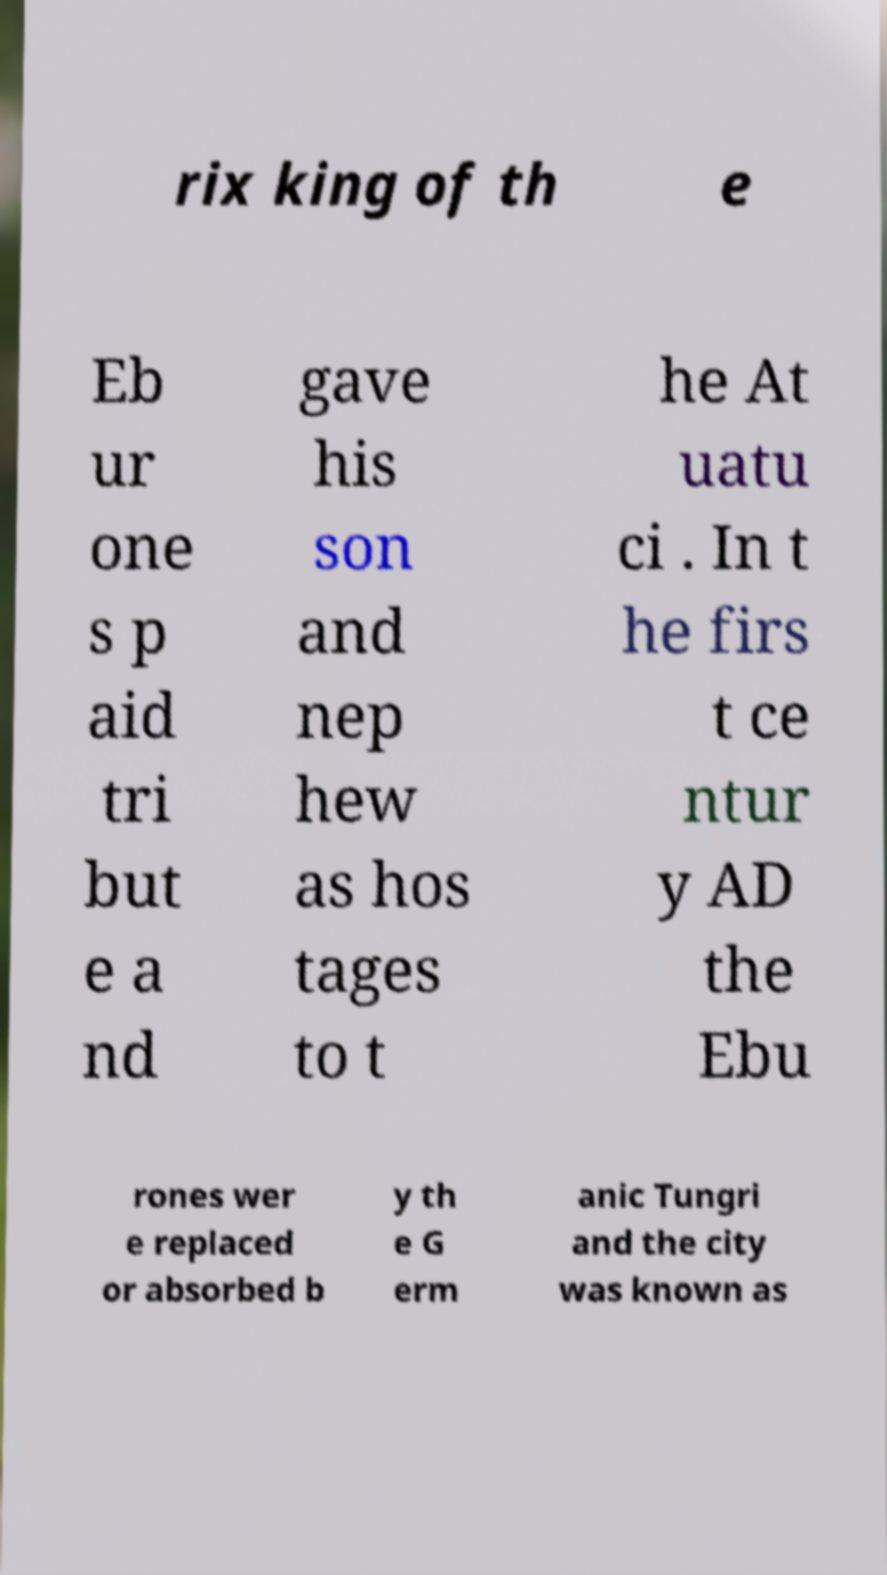Can you accurately transcribe the text from the provided image for me? rix king of th e Eb ur one s p aid tri but e a nd gave his son and nep hew as hos tages to t he At uatu ci . In t he firs t ce ntur y AD the Ebu rones wer e replaced or absorbed b y th e G erm anic Tungri and the city was known as 